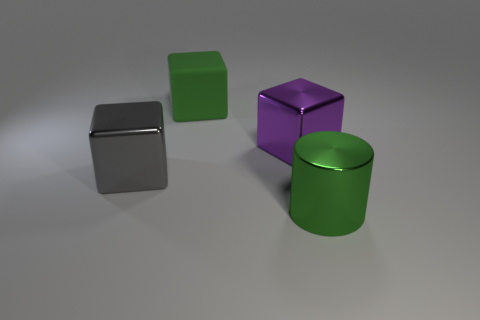Are there any other things that are made of the same material as the green cube?
Ensure brevity in your answer.  No. There is a purple thing that is the same material as the cylinder; what is its shape?
Your answer should be very brief. Cube. What number of green matte objects have the same shape as the green shiny object?
Keep it short and to the point. 0. Does the big green thing that is to the left of the large green cylinder have the same shape as the thing in front of the large gray object?
Your response must be concise. No. How many things are either big yellow rubber objects or things that are to the right of the big gray object?
Offer a very short reply. 3. What is the shape of the big object that is the same color as the matte cube?
Your answer should be compact. Cylinder. How many other gray cubes have the same size as the gray block?
Make the answer very short. 0. What number of purple objects are large cylinders or matte blocks?
Your response must be concise. 0. The green thing in front of the matte object that is behind the large gray object is what shape?
Ensure brevity in your answer.  Cylinder. There is another green object that is the same size as the matte thing; what is its shape?
Offer a terse response. Cylinder. 